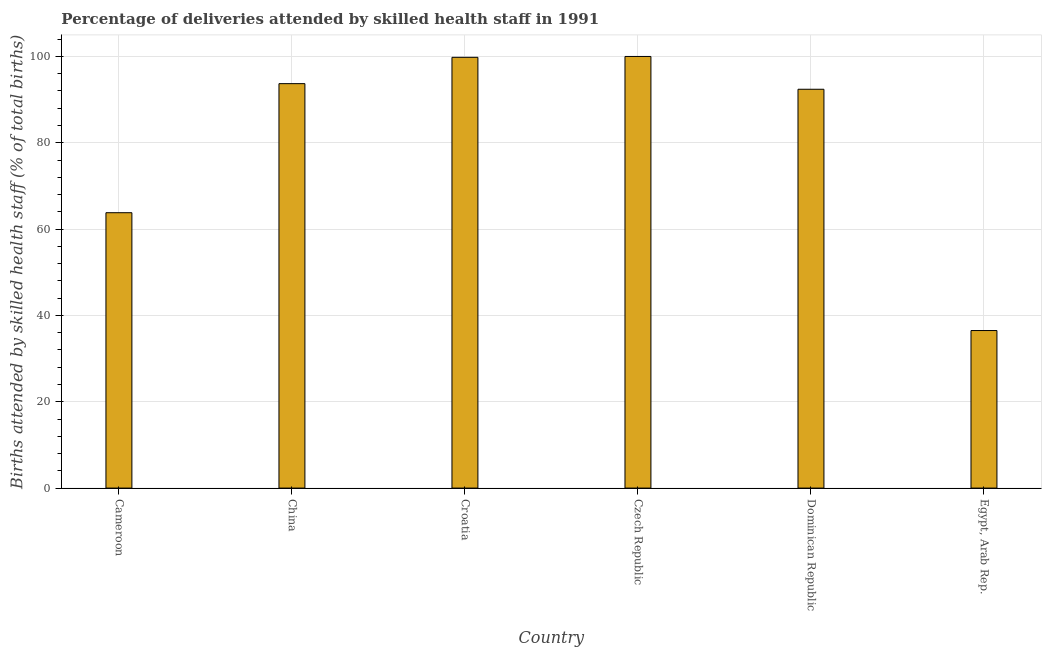Does the graph contain grids?
Offer a terse response. Yes. What is the title of the graph?
Your answer should be very brief. Percentage of deliveries attended by skilled health staff in 1991. What is the label or title of the X-axis?
Your answer should be very brief. Country. What is the label or title of the Y-axis?
Provide a succinct answer. Births attended by skilled health staff (% of total births). What is the number of births attended by skilled health staff in China?
Keep it short and to the point. 93.7. Across all countries, what is the minimum number of births attended by skilled health staff?
Offer a very short reply. 36.5. In which country was the number of births attended by skilled health staff maximum?
Give a very brief answer. Czech Republic. In which country was the number of births attended by skilled health staff minimum?
Provide a succinct answer. Egypt, Arab Rep. What is the sum of the number of births attended by skilled health staff?
Keep it short and to the point. 486.2. What is the difference between the number of births attended by skilled health staff in Cameroon and China?
Your answer should be very brief. -29.9. What is the average number of births attended by skilled health staff per country?
Your answer should be very brief. 81.03. What is the median number of births attended by skilled health staff?
Your answer should be compact. 93.05. What is the ratio of the number of births attended by skilled health staff in Dominican Republic to that in Egypt, Arab Rep.?
Ensure brevity in your answer.  2.53. Is the difference between the number of births attended by skilled health staff in Cameroon and Croatia greater than the difference between any two countries?
Make the answer very short. No. What is the difference between the highest and the lowest number of births attended by skilled health staff?
Your answer should be compact. 63.5. In how many countries, is the number of births attended by skilled health staff greater than the average number of births attended by skilled health staff taken over all countries?
Your response must be concise. 4. How many bars are there?
Ensure brevity in your answer.  6. Are all the bars in the graph horizontal?
Make the answer very short. No. What is the difference between two consecutive major ticks on the Y-axis?
Make the answer very short. 20. Are the values on the major ticks of Y-axis written in scientific E-notation?
Give a very brief answer. No. What is the Births attended by skilled health staff (% of total births) in Cameroon?
Your answer should be compact. 63.8. What is the Births attended by skilled health staff (% of total births) of China?
Offer a very short reply. 93.7. What is the Births attended by skilled health staff (% of total births) in Croatia?
Your answer should be compact. 99.8. What is the Births attended by skilled health staff (% of total births) in Dominican Republic?
Keep it short and to the point. 92.4. What is the Births attended by skilled health staff (% of total births) of Egypt, Arab Rep.?
Offer a terse response. 36.5. What is the difference between the Births attended by skilled health staff (% of total births) in Cameroon and China?
Offer a very short reply. -29.9. What is the difference between the Births attended by skilled health staff (% of total births) in Cameroon and Croatia?
Give a very brief answer. -36. What is the difference between the Births attended by skilled health staff (% of total births) in Cameroon and Czech Republic?
Offer a terse response. -36.2. What is the difference between the Births attended by skilled health staff (% of total births) in Cameroon and Dominican Republic?
Ensure brevity in your answer.  -28.6. What is the difference between the Births attended by skilled health staff (% of total births) in Cameroon and Egypt, Arab Rep.?
Provide a succinct answer. 27.3. What is the difference between the Births attended by skilled health staff (% of total births) in China and Czech Republic?
Give a very brief answer. -6.3. What is the difference between the Births attended by skilled health staff (% of total births) in China and Dominican Republic?
Provide a succinct answer. 1.3. What is the difference between the Births attended by skilled health staff (% of total births) in China and Egypt, Arab Rep.?
Your answer should be very brief. 57.2. What is the difference between the Births attended by skilled health staff (% of total births) in Croatia and Dominican Republic?
Your answer should be very brief. 7.4. What is the difference between the Births attended by skilled health staff (% of total births) in Croatia and Egypt, Arab Rep.?
Provide a short and direct response. 63.3. What is the difference between the Births attended by skilled health staff (% of total births) in Czech Republic and Egypt, Arab Rep.?
Your answer should be very brief. 63.5. What is the difference between the Births attended by skilled health staff (% of total births) in Dominican Republic and Egypt, Arab Rep.?
Offer a very short reply. 55.9. What is the ratio of the Births attended by skilled health staff (% of total births) in Cameroon to that in China?
Your answer should be compact. 0.68. What is the ratio of the Births attended by skilled health staff (% of total births) in Cameroon to that in Croatia?
Your answer should be compact. 0.64. What is the ratio of the Births attended by skilled health staff (% of total births) in Cameroon to that in Czech Republic?
Make the answer very short. 0.64. What is the ratio of the Births attended by skilled health staff (% of total births) in Cameroon to that in Dominican Republic?
Ensure brevity in your answer.  0.69. What is the ratio of the Births attended by skilled health staff (% of total births) in Cameroon to that in Egypt, Arab Rep.?
Offer a very short reply. 1.75. What is the ratio of the Births attended by skilled health staff (% of total births) in China to that in Croatia?
Your answer should be compact. 0.94. What is the ratio of the Births attended by skilled health staff (% of total births) in China to that in Czech Republic?
Keep it short and to the point. 0.94. What is the ratio of the Births attended by skilled health staff (% of total births) in China to that in Egypt, Arab Rep.?
Offer a terse response. 2.57. What is the ratio of the Births attended by skilled health staff (% of total births) in Croatia to that in Czech Republic?
Your answer should be compact. 1. What is the ratio of the Births attended by skilled health staff (% of total births) in Croatia to that in Egypt, Arab Rep.?
Give a very brief answer. 2.73. What is the ratio of the Births attended by skilled health staff (% of total births) in Czech Republic to that in Dominican Republic?
Make the answer very short. 1.08. What is the ratio of the Births attended by skilled health staff (% of total births) in Czech Republic to that in Egypt, Arab Rep.?
Give a very brief answer. 2.74. What is the ratio of the Births attended by skilled health staff (% of total births) in Dominican Republic to that in Egypt, Arab Rep.?
Ensure brevity in your answer.  2.53. 